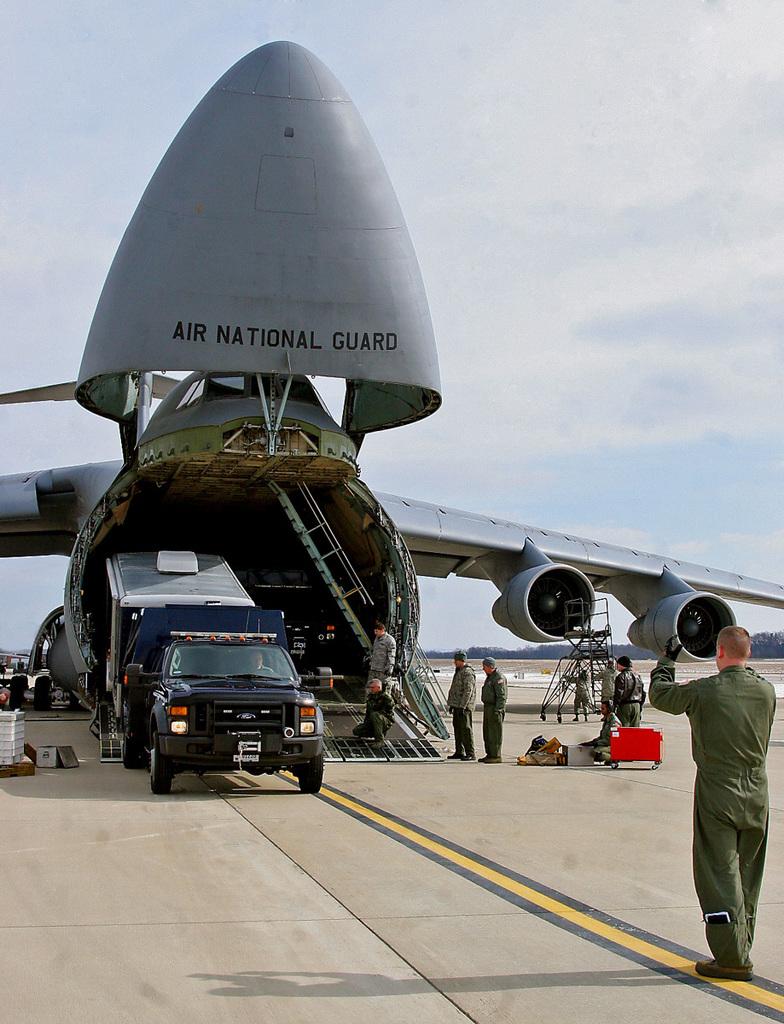What branch does this carrier belong to?
Your answer should be very brief. Air national guard. What brand is the car?
Make the answer very short. Ford. 